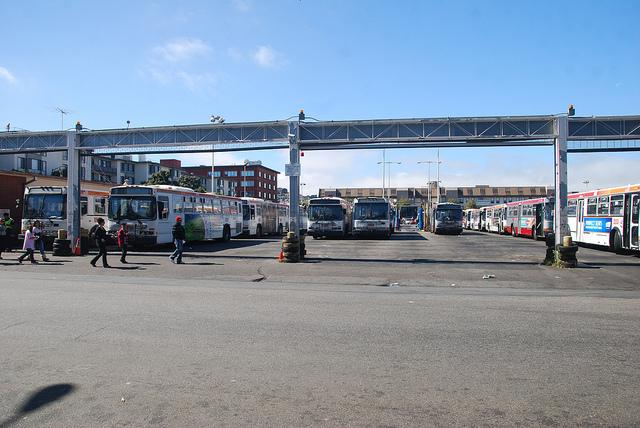How many rows of buses are visible? six 